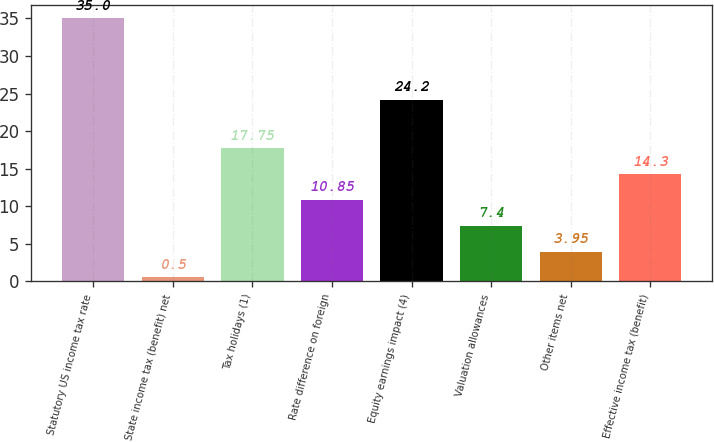Convert chart. <chart><loc_0><loc_0><loc_500><loc_500><bar_chart><fcel>Statutory US income tax rate<fcel>State income tax (benefit) net<fcel>Tax holidays (1)<fcel>Rate difference on foreign<fcel>Equity earnings impact (4)<fcel>Valuation allowances<fcel>Other items net<fcel>Effective income tax (benefit)<nl><fcel>35<fcel>0.5<fcel>17.75<fcel>10.85<fcel>24.2<fcel>7.4<fcel>3.95<fcel>14.3<nl></chart> 